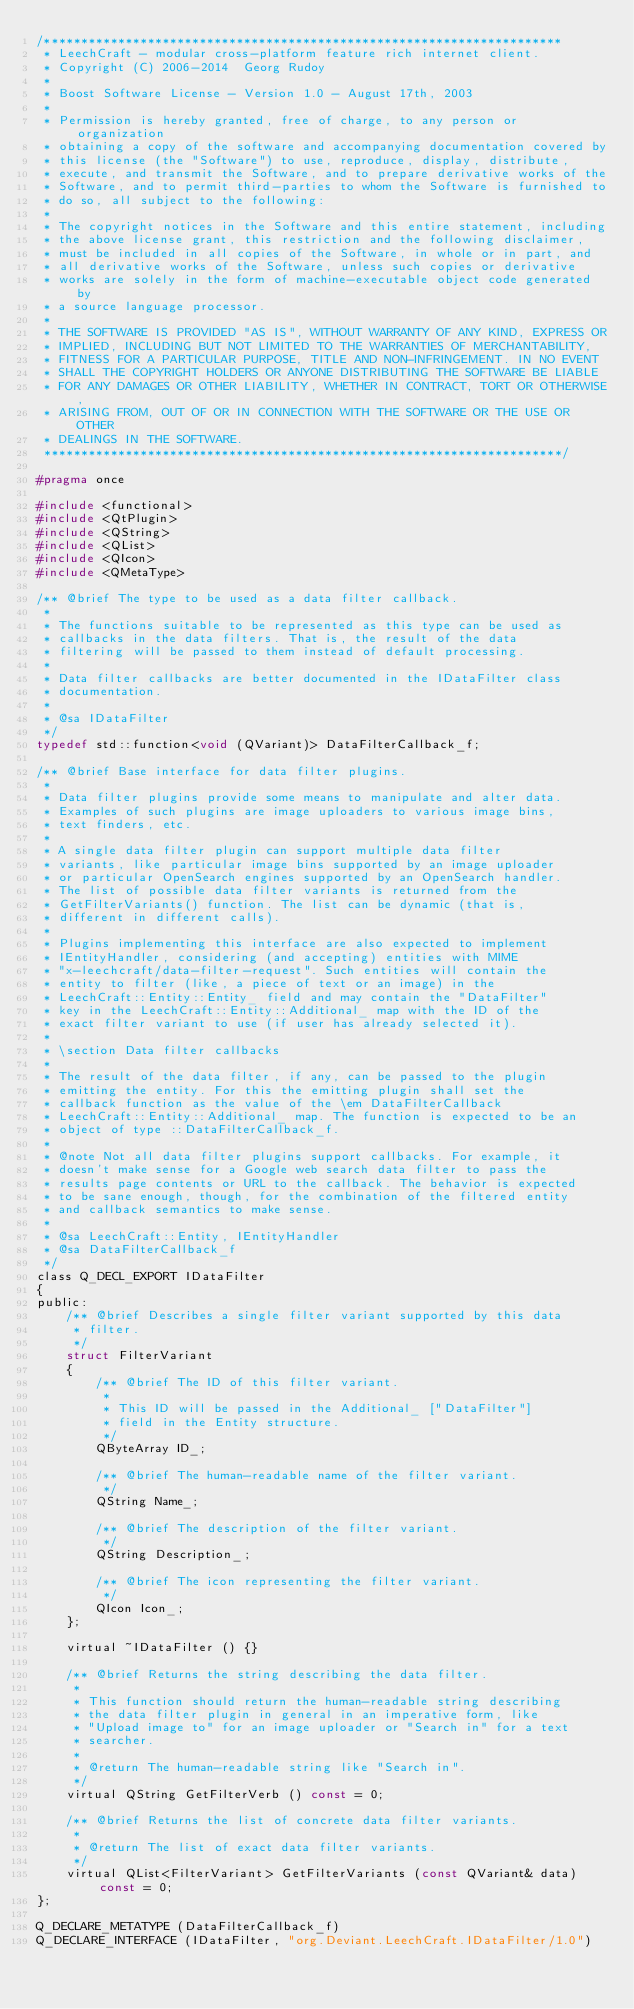Convert code to text. <code><loc_0><loc_0><loc_500><loc_500><_C_>/**********************************************************************
 * LeechCraft - modular cross-platform feature rich internet client.
 * Copyright (C) 2006-2014  Georg Rudoy
 *
 * Boost Software License - Version 1.0 - August 17th, 2003
 *
 * Permission is hereby granted, free of charge, to any person or organization
 * obtaining a copy of the software and accompanying documentation covered by
 * this license (the "Software") to use, reproduce, display, distribute,
 * execute, and transmit the Software, and to prepare derivative works of the
 * Software, and to permit third-parties to whom the Software is furnished to
 * do so, all subject to the following:
 *
 * The copyright notices in the Software and this entire statement, including
 * the above license grant, this restriction and the following disclaimer,
 * must be included in all copies of the Software, in whole or in part, and
 * all derivative works of the Software, unless such copies or derivative
 * works are solely in the form of machine-executable object code generated by
 * a source language processor.
 *
 * THE SOFTWARE IS PROVIDED "AS IS", WITHOUT WARRANTY OF ANY KIND, EXPRESS OR
 * IMPLIED, INCLUDING BUT NOT LIMITED TO THE WARRANTIES OF MERCHANTABILITY,
 * FITNESS FOR A PARTICULAR PURPOSE, TITLE AND NON-INFRINGEMENT. IN NO EVENT
 * SHALL THE COPYRIGHT HOLDERS OR ANYONE DISTRIBUTING THE SOFTWARE BE LIABLE
 * FOR ANY DAMAGES OR OTHER LIABILITY, WHETHER IN CONTRACT, TORT OR OTHERWISE,
 * ARISING FROM, OUT OF OR IN CONNECTION WITH THE SOFTWARE OR THE USE OR OTHER
 * DEALINGS IN THE SOFTWARE.
 **********************************************************************/

#pragma once

#include <functional>
#include <QtPlugin>
#include <QString>
#include <QList>
#include <QIcon>
#include <QMetaType>

/** @brief The type to be used as a data filter callback.
 *
 * The functions suitable to be represented as this type can be used as
 * callbacks in the data filters. That is, the result of the data
 * filtering will be passed to them instead of default processing.
 *
 * Data filter callbacks are better documented in the IDataFilter class
 * documentation.
 *
 * @sa IDataFilter
 */
typedef std::function<void (QVariant)> DataFilterCallback_f;

/** @brief Base interface for data filter plugins.
 *
 * Data filter plugins provide some means to manipulate and alter data.
 * Examples of such plugins are image uploaders to various image bins,
 * text finders, etc.
 *
 * A single data filter plugin can support multiple data filter
 * variants, like particular image bins supported by an image uploader
 * or particular OpenSearch engines supported by an OpenSearch handler.
 * The list of possible data filter variants is returned from the
 * GetFilterVariants() function. The list can be dynamic (that is,
 * different in different calls).
 *
 * Plugins implementing this interface are also expected to implement
 * IEntityHandler, considering (and accepting) entities with MIME
 * "x-leechcraft/data-filter-request". Such entities will contain the
 * entity to filter (like, a piece of text or an image) in the
 * LeechCraft::Entity::Entity_ field and may contain the "DataFilter"
 * key in the LeechCraft::Entity::Additional_ map with the ID of the
 * exact filter variant to use (if user has already selected it).
 *
 * \section Data filter callbacks
 *
 * The result of the data filter, if any, can be passed to the plugin
 * emitting the entity. For this the emitting plugin shall set the
 * callback function as the value of the \em DataFilterCallback
 * LeechCraft::Entity::Additional_ map. The function is expected to be an
 * object of type ::DataFilterCallback_f.
 *
 * @note Not all data filter plugins support callbacks. For example, it
 * doesn't make sense for a Google web search data filter to pass the
 * results page contents or URL to the callback. The behavior is expected
 * to be sane enough, though, for the combination of the filtered entity
 * and callback semantics to make sense.
 *
 * @sa LeechCraft::Entity, IEntityHandler
 * @sa DataFilterCallback_f
 */
class Q_DECL_EXPORT IDataFilter
{
public:
	/** @brief Describes a single filter variant supported by this data
	 * filter.
	 */
	struct FilterVariant
	{
		/** @brief The ID of this filter variant.
		 *
		 * This ID will be passed in the Additional_ ["DataFilter"]
		 * field in the Entity structure.
		 */
		QByteArray ID_;

		/** @brief The human-readable name of the filter variant.
		 */
		QString Name_;

		/** @brief The description of the filter variant.
		 */
		QString Description_;

		/** @brief The icon representing the filter variant.
		 */
		QIcon Icon_;
	};

	virtual ~IDataFilter () {}

	/** @brief Returns the string describing the data filter.
	 *
	 * This function should return the human-readable string describing
	 * the data filter plugin in general in an imperative form, like
	 * "Upload image to" for an image uploader or "Search in" for a text
	 * searcher.
	 *
	 * @return The human-readable string like "Search in".
	 */
	virtual QString GetFilterVerb () const = 0;

	/** @brief Returns the list of concrete data filter variants.
	 *
	 * @return The list of exact data filter variants.
	 */
	virtual QList<FilterVariant> GetFilterVariants (const QVariant& data) const = 0;
};

Q_DECLARE_METATYPE (DataFilterCallback_f)
Q_DECLARE_INTERFACE (IDataFilter, "org.Deviant.LeechCraft.IDataFilter/1.0")
</code> 